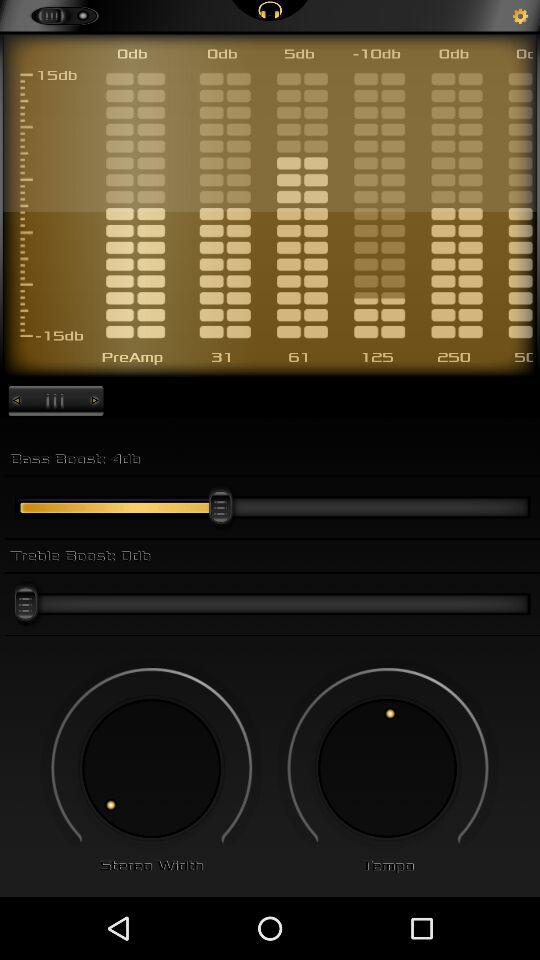How many decibels greater is the bass boost than the treble boost?
Answer the question using a single word or phrase. 4 